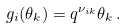Convert formula to latex. <formula><loc_0><loc_0><loc_500><loc_500>g _ { i } ( \theta _ { k } ) = q ^ { \nu _ { i k } } \theta _ { k } \, .</formula> 